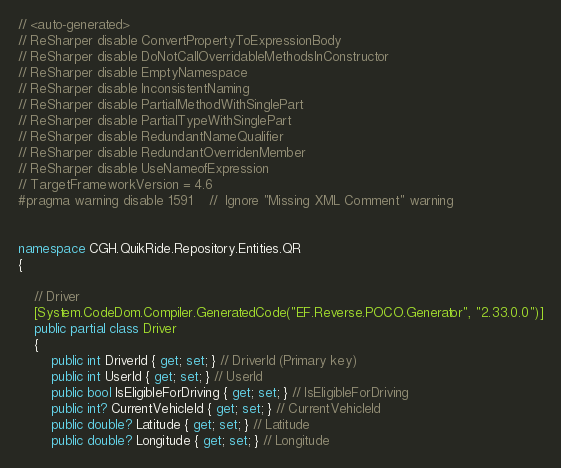Convert code to text. <code><loc_0><loc_0><loc_500><loc_500><_C#_>// <auto-generated>
// ReSharper disable ConvertPropertyToExpressionBody
// ReSharper disable DoNotCallOverridableMethodsInConstructor
// ReSharper disable EmptyNamespace
// ReSharper disable InconsistentNaming
// ReSharper disable PartialMethodWithSinglePart
// ReSharper disable PartialTypeWithSinglePart
// ReSharper disable RedundantNameQualifier
// ReSharper disable RedundantOverridenMember
// ReSharper disable UseNameofExpression
// TargetFrameworkVersion = 4.6
#pragma warning disable 1591    //  Ignore "Missing XML Comment" warning


namespace CGH.QuikRide.Repository.Entities.QR
{

    // Driver
    [System.CodeDom.Compiler.GeneratedCode("EF.Reverse.POCO.Generator", "2.33.0.0")]
    public partial class Driver
    {
        public int DriverId { get; set; } // DriverId (Primary key)
        public int UserId { get; set; } // UserId
        public bool IsEligibleForDriving { get; set; } // IsEligibleForDriving
        public int? CurrentVehicleId { get; set; } // CurrentVehicleId
        public double? Latitude { get; set; } // Latitude
        public double? Longitude { get; set; } // Longitude</code> 